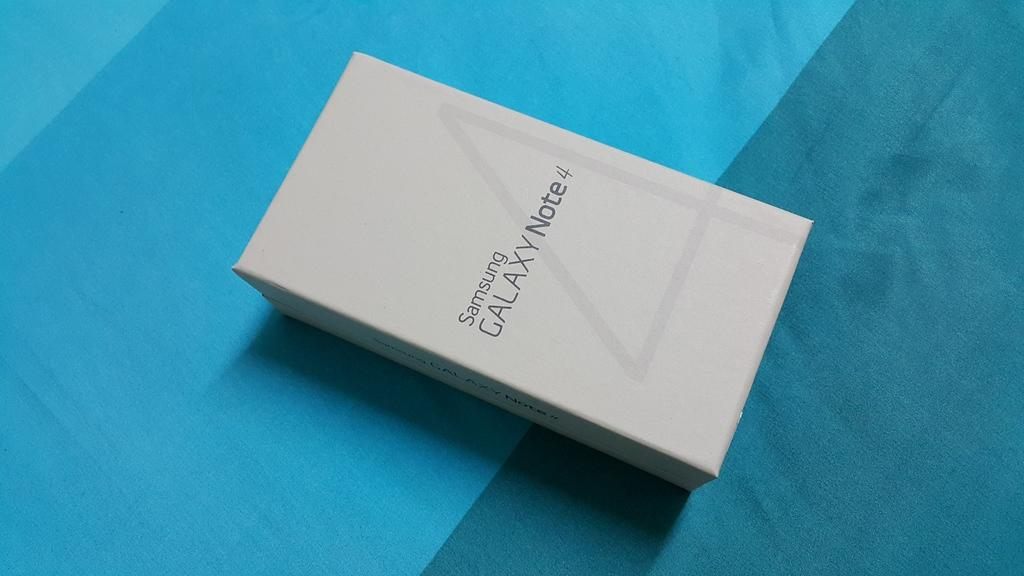<image>
Present a compact description of the photo's key features. A Samsung Galaxy box sits on a blue fabric. 